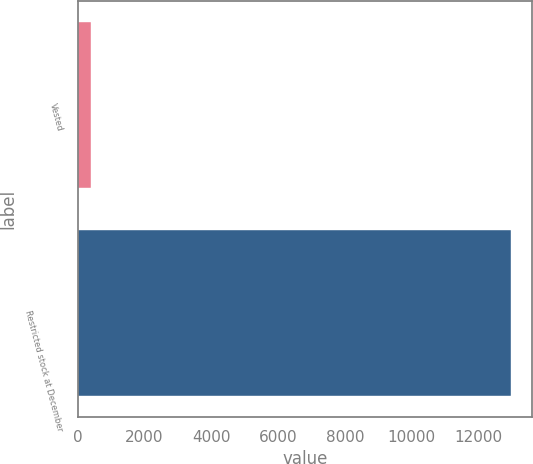Convert chart to OTSL. <chart><loc_0><loc_0><loc_500><loc_500><bar_chart><fcel>Vested<fcel>Restricted stock at December<nl><fcel>405<fcel>12964<nl></chart> 